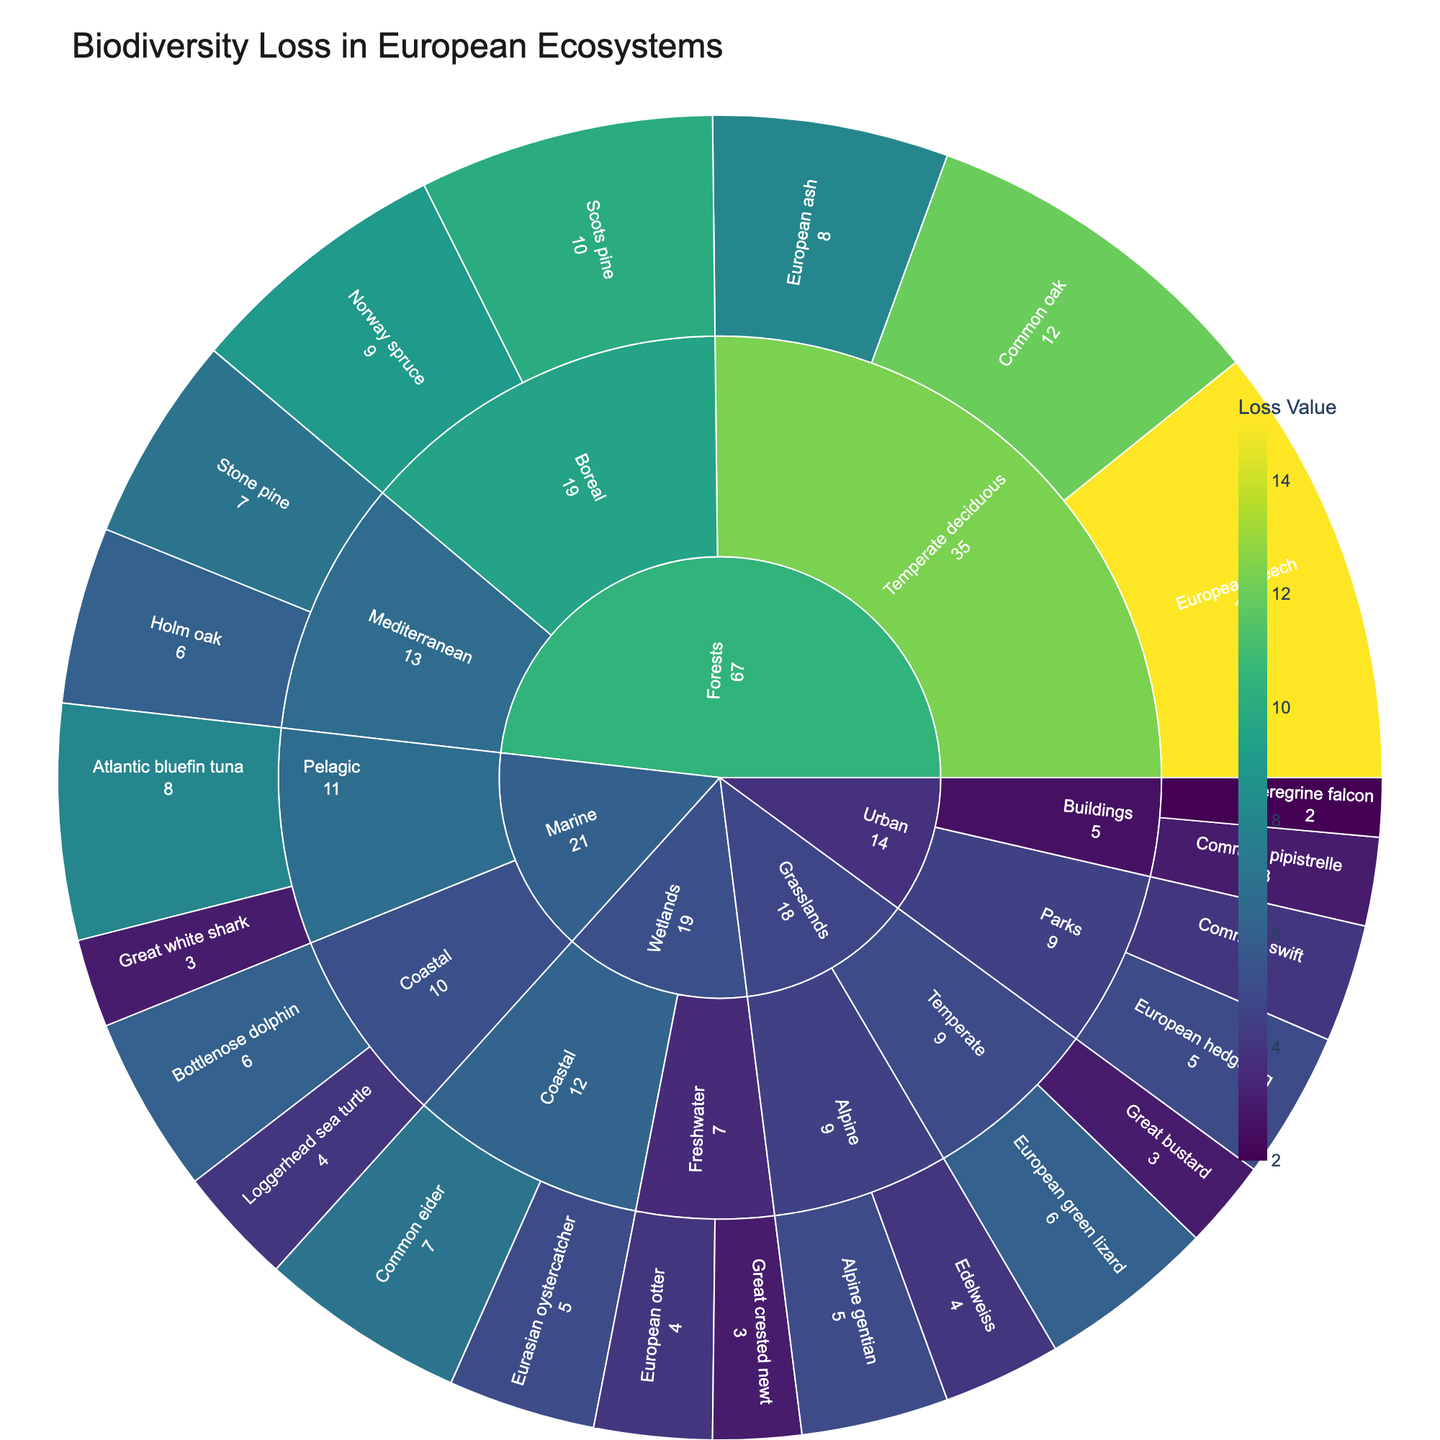Which habitat category has the highest biodiversity loss value? The habitat category with the highest cumulative biodiversity loss value is observed in the "Forests" category, as seen by the size of the segment in the sunburst plot.
Answer: Forests What is the combined biodiversity loss for Boreal forests? The Boreal subcategory includes Scots pine with a loss value of 10 and Norway spruce with a loss value of 9. Adding these together gives a total loss of 19.
Answer: 19 Which species has the highest biodiversity loss value in Wetlands? The species with the highest biodiversity loss value within the Wetlands category is the Common eider in the Coastal subcategory, with a value of 7.
Answer: Common eider How does the biodiversity loss of European beech compare to Common oak in the Temperate deciduous forests? The European beech has a loss value of 15, while the Common oak has a value of 12. European beech has a higher biodiversity loss than Common oak in the Temperate deciduous forests.
Answer: European beech has a higher loss What is the smallest biodiversity loss value recorded in Urban habitats? The smallest biodiversity loss value in Urban habitats is for the Peregrine falcon in the Buildings subcategory, which has a loss value of 2.
Answer: 2 What is the average biodiversity loss value for species in the Marine category? In the Marine category, the loss values are Bottlenose dolphin (6), Loggerhead sea turtle (4), Atlantic bluefin tuna (8), and Great white shark (3). The total is (6 + 4 + 8 + 3) = 21. Dividing by 4 gives an average of 5.25.
Answer: 5.25 Which habitat subcategory in Grasslands has a higher total biodiversity loss value? Alpine or Temperate? The Alpine subcategory has Alpine gentian (5) and Edelweiss (4), totaling 9. The Temperate subcategory has the European green lizard (6) and Great bustard (3), also totaling 9.
Answer: Equal Which species have a biodiversity loss value of 7? Species with a biodiversity loss value of 7 are Stone pine in Mediterranean forests and Common eider in Coastal wetlands.
Answer: Stone pine and Common eider Is the biodiversity loss greater in Temperate deciduous forests or Mediterranean forests? The Temperate deciduous forests include European beech (15), Common oak (12), and European ash (8), totaling 35. The Mediterranean forests include Stone pine (7) and Holm oak (6), totaling 13. Thus, the biodiversity loss is greater in Temperate deciduous forests.
Answer: Temperate deciduous forests Compare the biodiversity loss in Coastal habitats across Wetlands and Marine categories. In Coastal Wetlands, the species loss values are Common eider (7) and Eurasian oystercatcher (5), totaling 12. In Coastal Marine, the species are Bottlenose dolphin (6) and Loggerhead sea turtle (4), totaling 10. Therefore, Coastal Wetlands have a greater biodiversity loss than Coastal Marine.
Answer: Coastal Wetlands have greater loss 